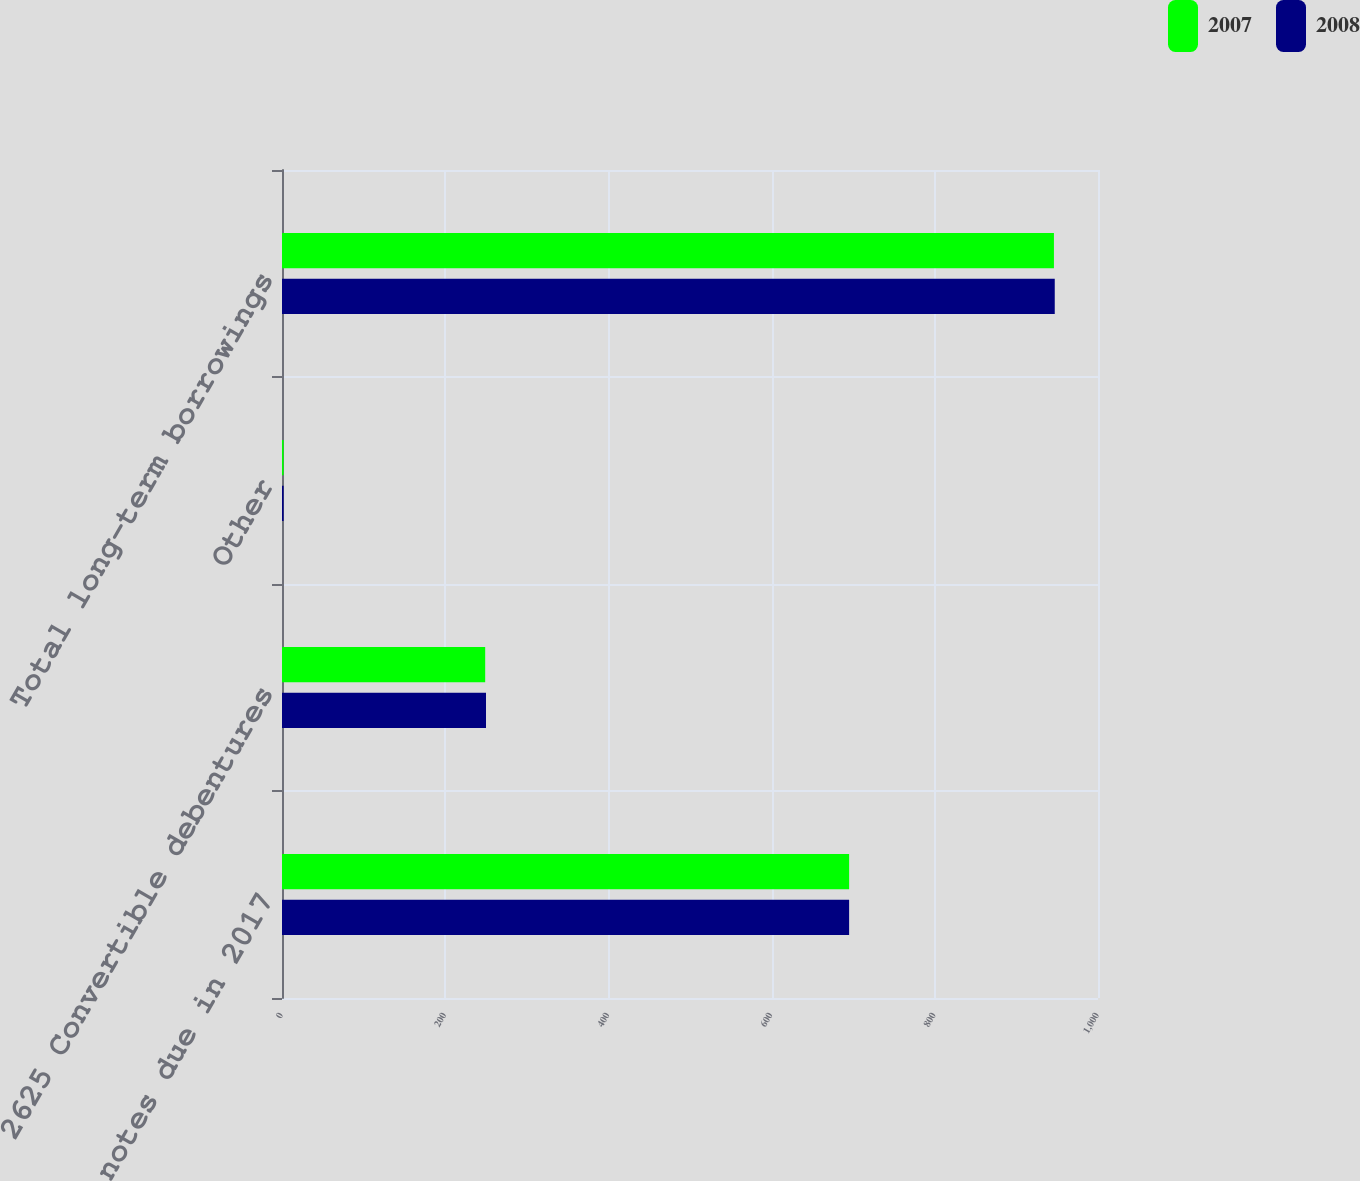Convert chart. <chart><loc_0><loc_0><loc_500><loc_500><stacked_bar_chart><ecel><fcel>625 Senior notes due in 2017<fcel>2625 Convertible debentures<fcel>Other<fcel>Total long-term borrowings<nl><fcel>2007<fcel>695<fcel>249<fcel>2<fcel>946<nl><fcel>2008<fcel>695<fcel>250<fcel>2<fcel>947<nl></chart> 